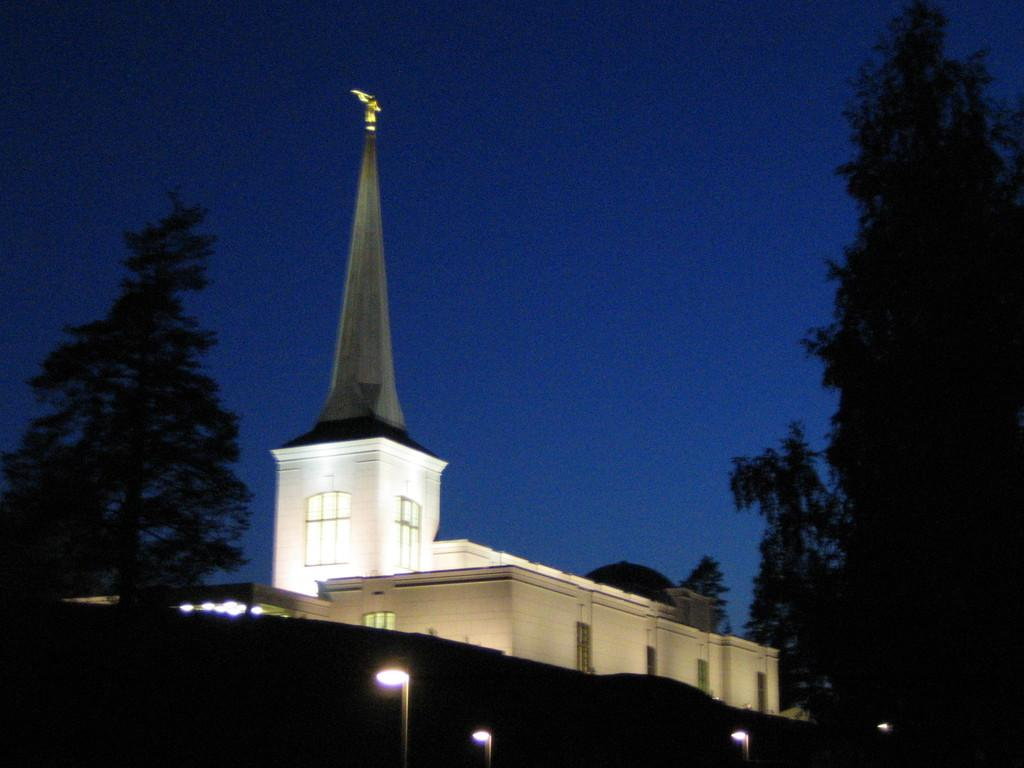What type of natural elements can be seen in the image? There are trees in the image. What artificial elements can be seen in the image? There are lights and a building in the image. What organization is responsible for the maintenance of the trees in the image? There is no information about an organization responsible for the maintenance of the trees in the image. Can you see the thumb of the person who took the photo in the image? There is no thumb visible in the image. 